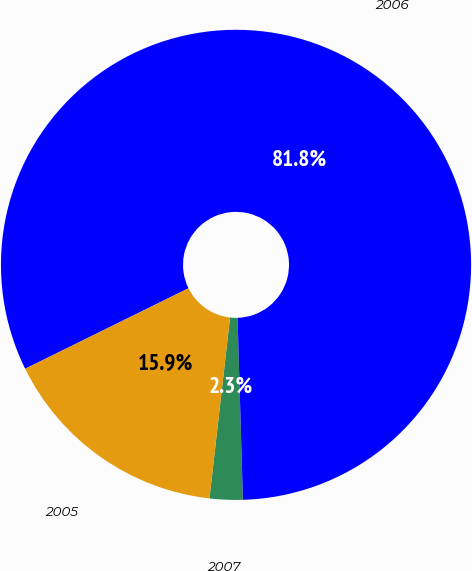Convert chart. <chart><loc_0><loc_0><loc_500><loc_500><pie_chart><fcel>2007<fcel>2006<fcel>2005<nl><fcel>2.27%<fcel>81.82%<fcel>15.91%<nl></chart> 